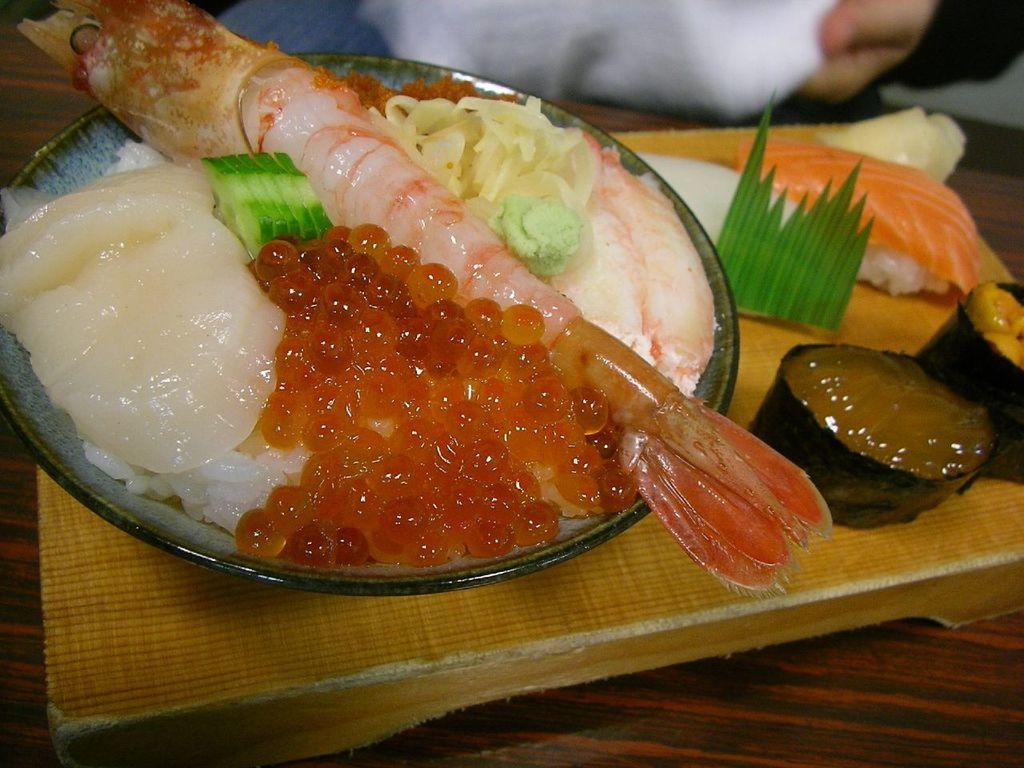What type of food is on the plate in the image? There is a plateful of seafood in the image. What is the plateful of seafood placed on? The plateful of seafood is placed on a wooden table. What type of drum is visible on the wooden table in the image? There is no drum present in the image; it only features a plateful of seafood on a wooden table. 